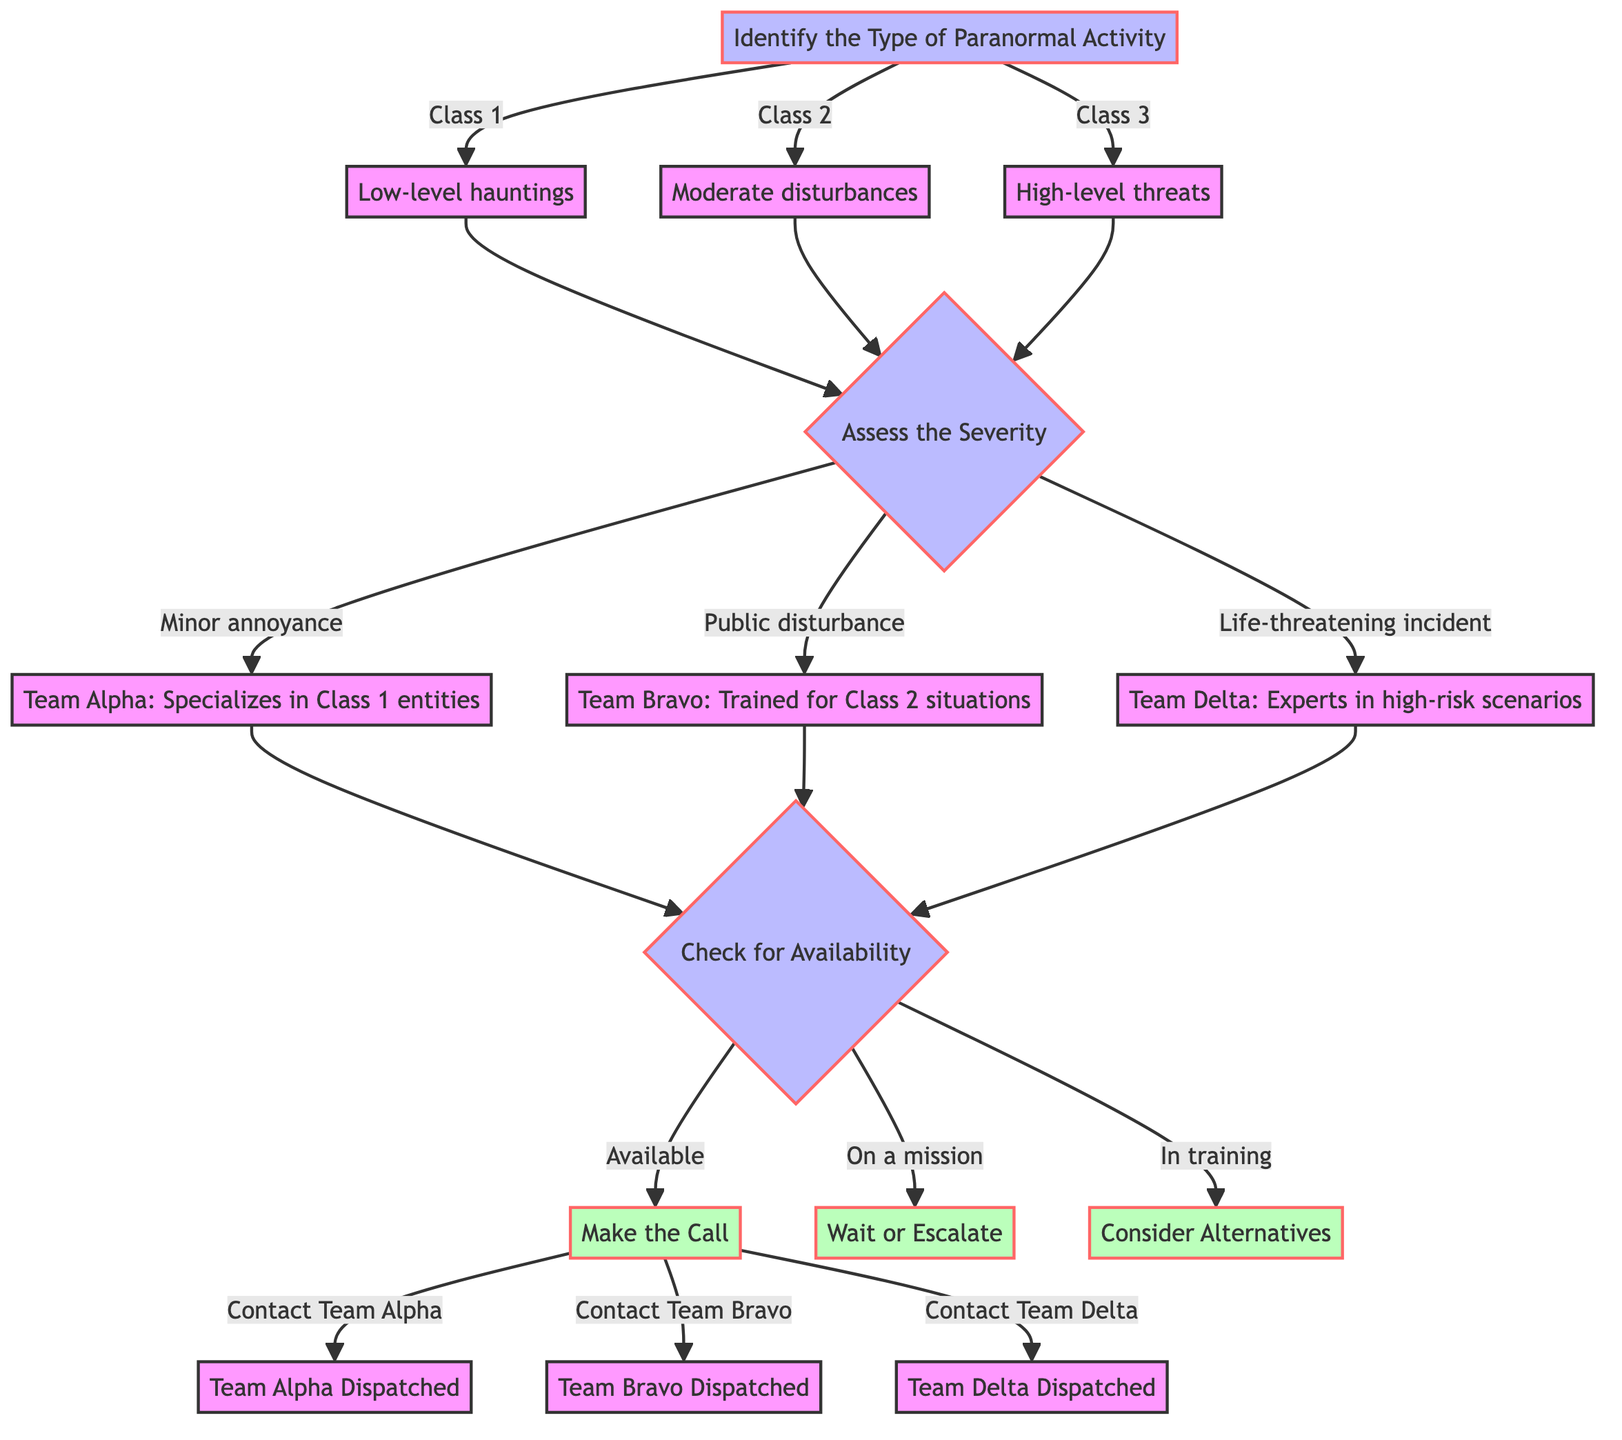What are the three types of paranormal activity identified? The diagram indicates three types of paranormal activity: Class 1 (Low-level hauntings), Class 2 (Moderate disturbances), and Class 3 (High-level threats).
Answer: Class 1, Class 2, Class 3 Which team specializes in Class 1 entities? According to the flowchart, Team Alpha is designated as specializing in Class 1 entities that deal with low-level hauntings.
Answer: Team Alpha How many teams are evaluated for expertise in the diagram? The diagram lists three teams: Team Alpha, Team Bravo, and Team Delta, making a total of three teams evaluated for their expertise according to the severity of the incident.
Answer: 3 What happens if a team is "On a mission"? If a team is identified as "On a mission", the flowchart indicates to "Wait or Escalate" instead of making a call, guiding the decision-making process based on team availability.
Answer: Wait or Escalate What is the outcome of contacting Team Bravo? The diagram indicates that if you make the call to contact Team Bravo, the result will be "Team Bravo Dispatched", showing the action taken after the decision is made.
Answer: Team Bravo Dispatched If a paranormal activity is assessed as a "Public disturbance", which team should be contacted? When the situation is assessed as a "Public disturbance", the flowchart directs to Team Bravo, which specializes in handling Class 2 situations, hence it is the recommended team to contact.
Answer: Contact Team Bravo What are the options available for checking team availability? The flowchart shows three options for checking team availability: Available, On a mission, and In training. These options guide the decision-making once a team has been evaluated.
Answer: Available, On a mission, In training What leads to making the call to a Ghostbusters team? To make the call, the process first requires the identification of the type of paranormal activity, assessing its severity, and then checking the team's availability. If available, it concludes with making the call.
Answer: Make the Call What is the first step in the decision-making process? The initial step according to the flowchart is to "Identify the Type of Paranormal Activity," which serves as the starting point for selecting which team to call.
Answer: Identify the Type of Paranormal Activity 